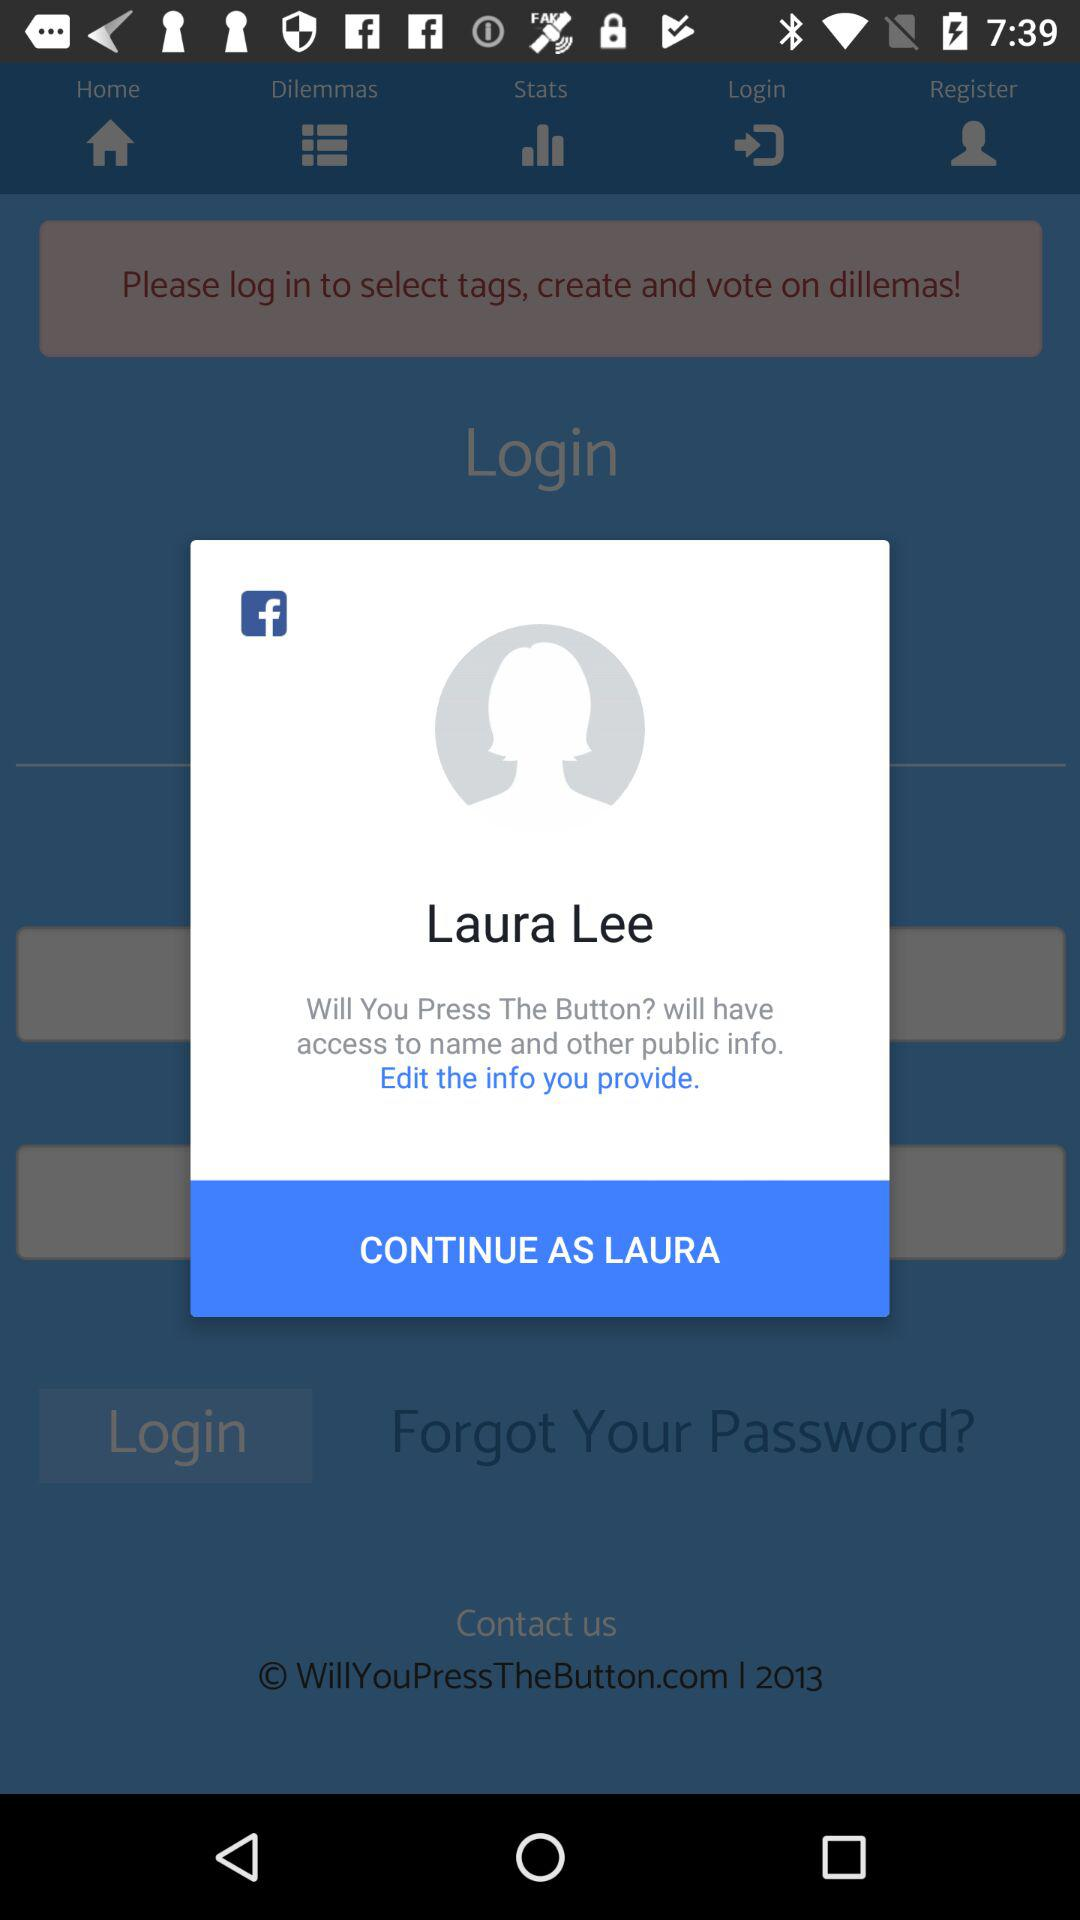What is the user name? The user name is Laura Lee. 